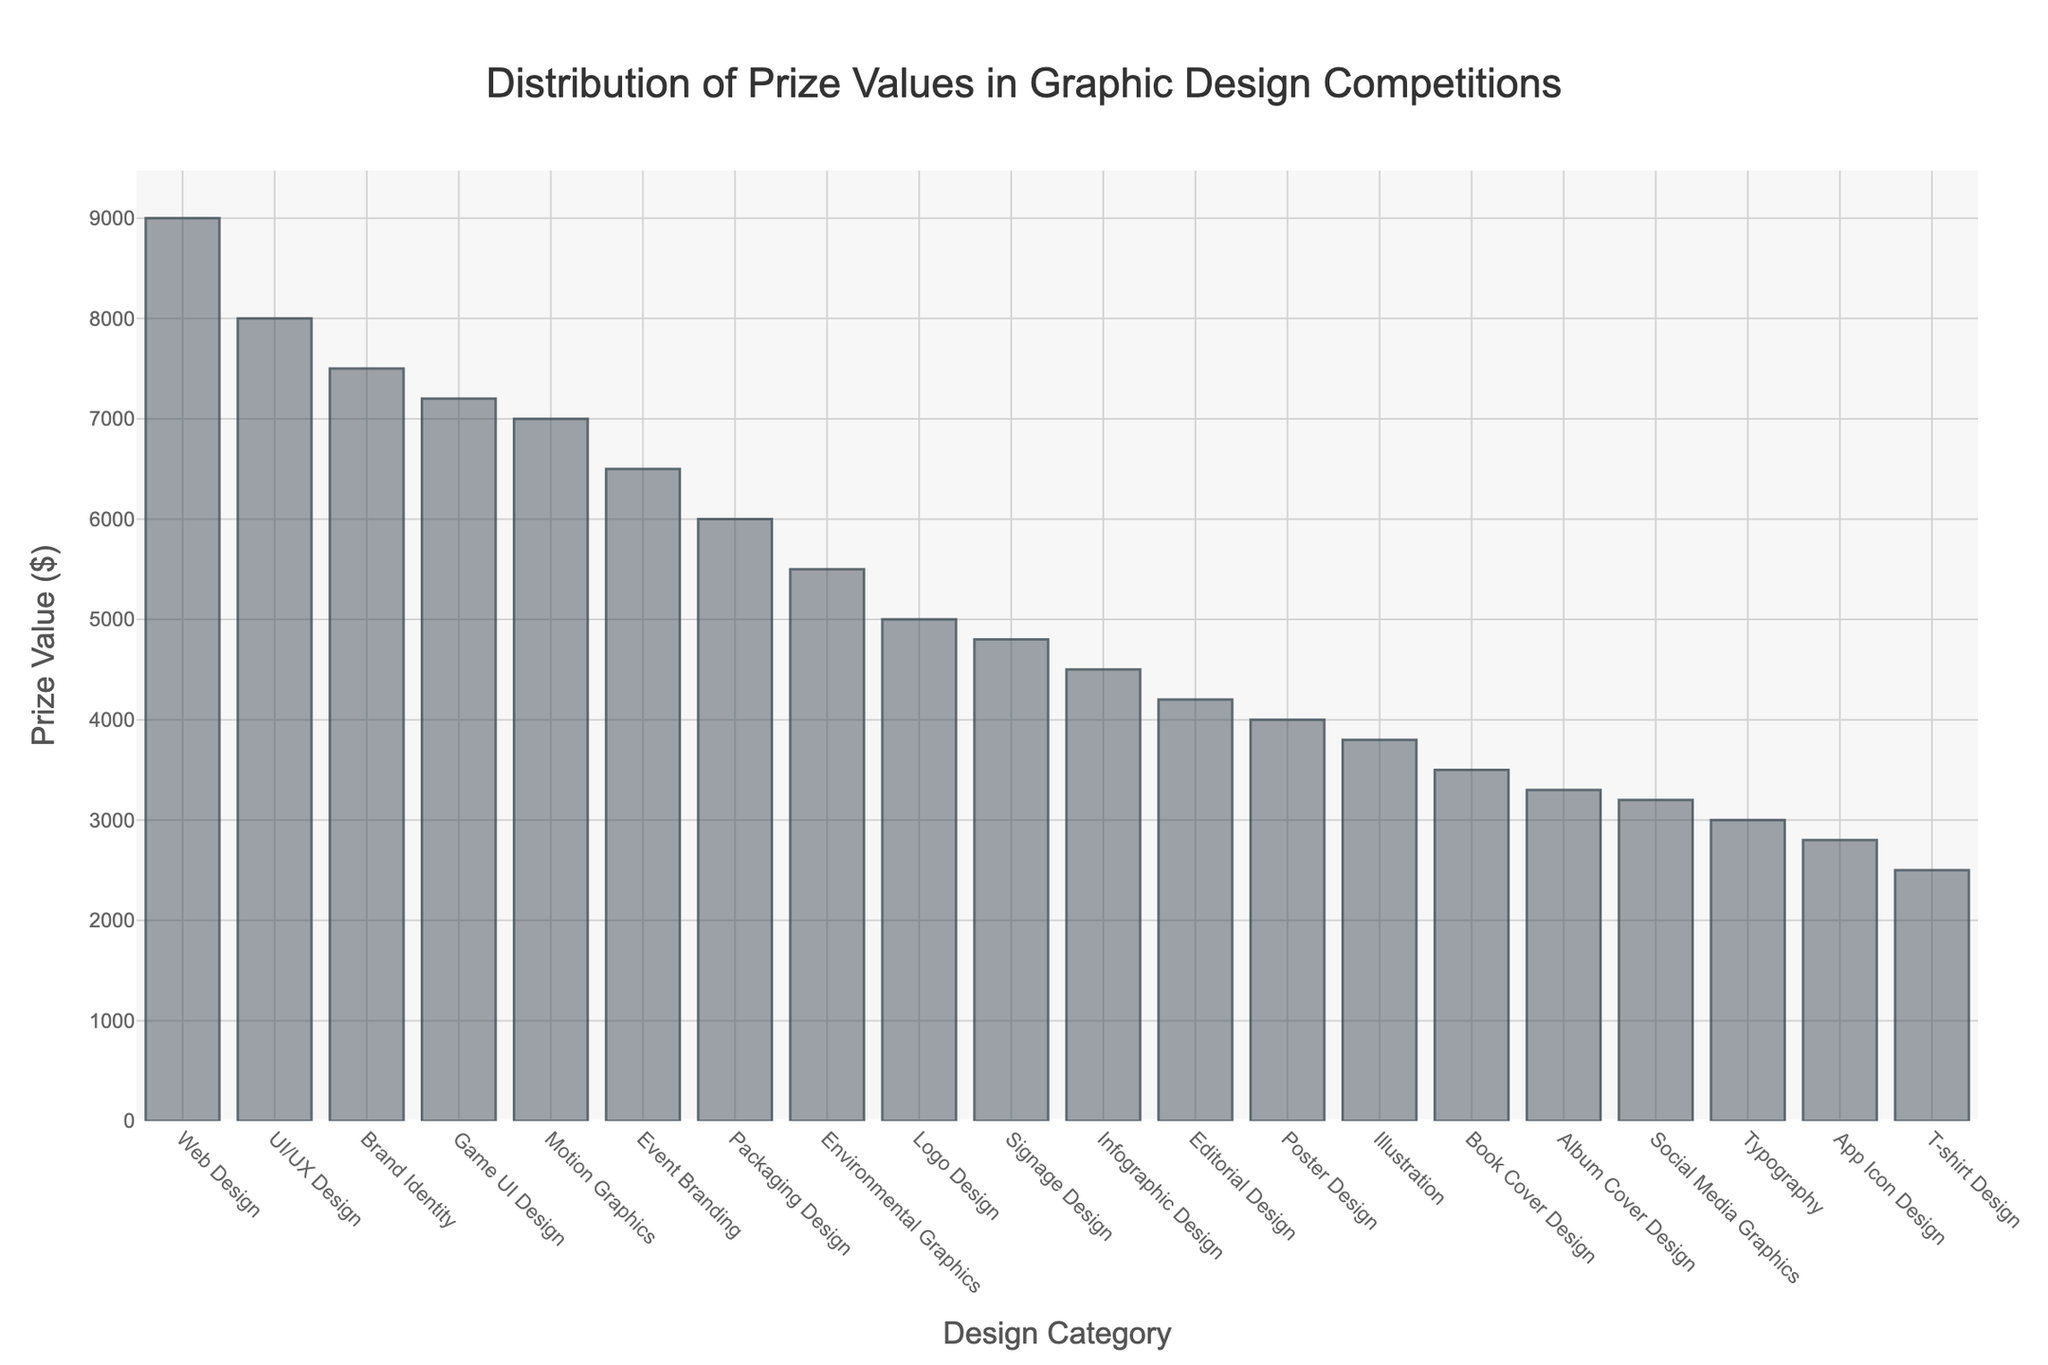What is the highest prize value in the graphic design competitions? The highest prize value is found by observing the tallest bar in the Manhattan plot, which corresponds to the Web Design category.
Answer: 9000 Which category has the lowest prize value? The lowest prize value is represented by the shortest bar in the Manhattan plot, which corresponds to the T-shirt Design category.
Answer: 2500 What is the total prize value for all categories combined? Add up the prize values for all the categories: 5000 + 7500 + 6000 + 3500 + 4000 + 8000 + 9000 + 4500 + 3000 + 7000 + 5500 + 4200 + 3800 + 3200 + 2800 + 2500 + 3300 + 6500 + 4800 + 7200 = 108800.
Answer: 108800 How many categories have a prize value greater than $5000? Count the number of bars that have a height corresponding to prize values greater than 5000. These categories are: Brand Identity, Packaging Design, UI/UX Design, Web Design, Motion Graphics, Environmental Graphics, Event Branding, and Game UI Design, totaling 8 categories.
Answer: 8 Which two categories have the closest prize values? The two closest prize values can be found by looking for bars of nearly equal height. These are Editorial Design and Poster Design, with prize values of $4200 and $4000, respectively. The difference is 200, which is the smallest among all the differences.
Answer: Editorial Design and Poster Design What is the difference in prize value between Web Design and Logo Design? The prize value for Web Design is 9000 and for Logo Design, it is 5000. The difference is calculated as 9000 - 5000 = 4000.
Answer: 4000 Is the prize value for Book Cover Design higher or lower than that for Infographic Design? Compare the heights of the bars for Book Cover Design and Infographic Design. Book Cover Design has a prize value of 3500, while Infographic Design has a prize value of 4500. Therefore, it is lower.
Answer: Lower What is the average prize value across all categories? Sum all the prize values and divide by the number of categories: (108800 / 20) = 5440.
Answer: 5440 Is the prize value for T-shirt Design half of anything else? The prize value for T-shirt Design is 2500. Check if there is any other category with a prize value of 5000, which would be double 2500. Logo Design has a prize of 5000, making T-shirt Design exactly half of Logo Design.
Answer: Yes Arrange the top three categories in ascending order of prize value. Identify the top three categories with the highest prize values: Web Design (9000), UI/UX Design (8000), and Brand Identity (7500). Sort them in ascending order: Brand Identity, UI/UX Design, Web Design.
Answer: Brand Identity, UI/UX Design, Web Design 